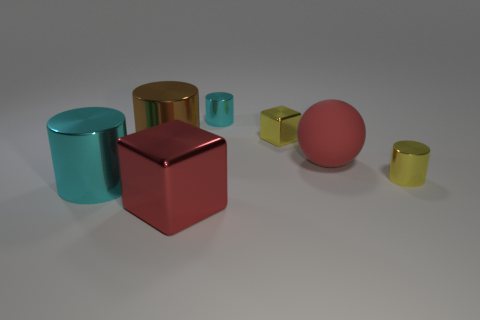The thing that is both on the left side of the large red metal cube and in front of the small yellow metallic cylinder is what color?
Ensure brevity in your answer.  Cyan. There is a cyan metallic cylinder that is behind the rubber ball; is its size the same as the yellow shiny cylinder?
Your answer should be very brief. Yes. How many objects are either objects in front of the large brown cylinder or tiny shiny cylinders?
Your answer should be very brief. 5. Is there a metallic cube of the same size as the brown metal cylinder?
Offer a terse response. Yes. What is the material of the sphere that is the same size as the brown shiny cylinder?
Keep it short and to the point. Rubber. What shape is the big metal thing that is both on the right side of the big cyan metal thing and in front of the big brown metallic cylinder?
Your response must be concise. Cube. There is a large metallic object behind the yellow metal cylinder; what is its color?
Make the answer very short. Brown. What is the size of the metallic object that is on the right side of the tiny cyan cylinder and left of the matte object?
Provide a short and direct response. Small. Is the material of the small yellow cube the same as the large thing that is behind the matte ball?
Give a very brief answer. Yes. What number of small yellow metal things have the same shape as the big cyan object?
Make the answer very short. 1. 